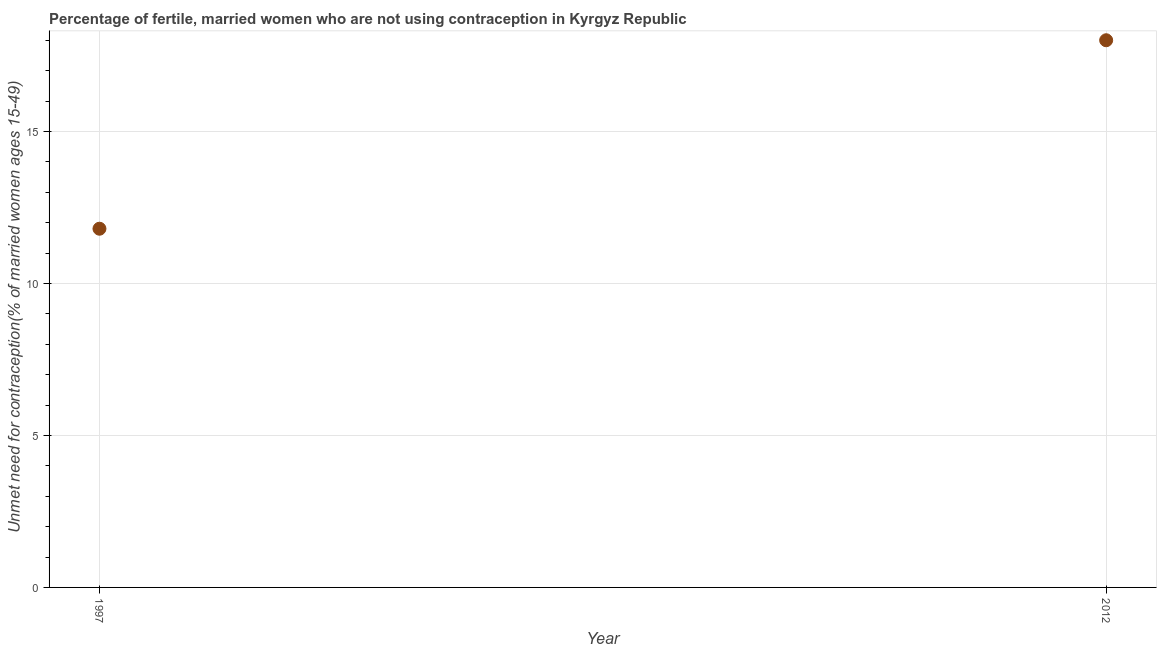What is the number of married women who are not using contraception in 1997?
Offer a terse response. 11.8. Across all years, what is the minimum number of married women who are not using contraception?
Ensure brevity in your answer.  11.8. In which year was the number of married women who are not using contraception minimum?
Provide a short and direct response. 1997. What is the sum of the number of married women who are not using contraception?
Provide a short and direct response. 29.8. What is the difference between the number of married women who are not using contraception in 1997 and 2012?
Provide a succinct answer. -6.2. What is the average number of married women who are not using contraception per year?
Make the answer very short. 14.9. Do a majority of the years between 2012 and 1997 (inclusive) have number of married women who are not using contraception greater than 4 %?
Give a very brief answer. No. What is the ratio of the number of married women who are not using contraception in 1997 to that in 2012?
Make the answer very short. 0.66. Is the number of married women who are not using contraception in 1997 less than that in 2012?
Your answer should be compact. Yes. In how many years, is the number of married women who are not using contraception greater than the average number of married women who are not using contraception taken over all years?
Your answer should be very brief. 1. Does the graph contain any zero values?
Keep it short and to the point. No. What is the title of the graph?
Make the answer very short. Percentage of fertile, married women who are not using contraception in Kyrgyz Republic. What is the label or title of the Y-axis?
Provide a succinct answer.  Unmet need for contraception(% of married women ages 15-49). What is the difference between the  Unmet need for contraception(% of married women ages 15-49) in 1997 and 2012?
Ensure brevity in your answer.  -6.2. What is the ratio of the  Unmet need for contraception(% of married women ages 15-49) in 1997 to that in 2012?
Offer a terse response. 0.66. 